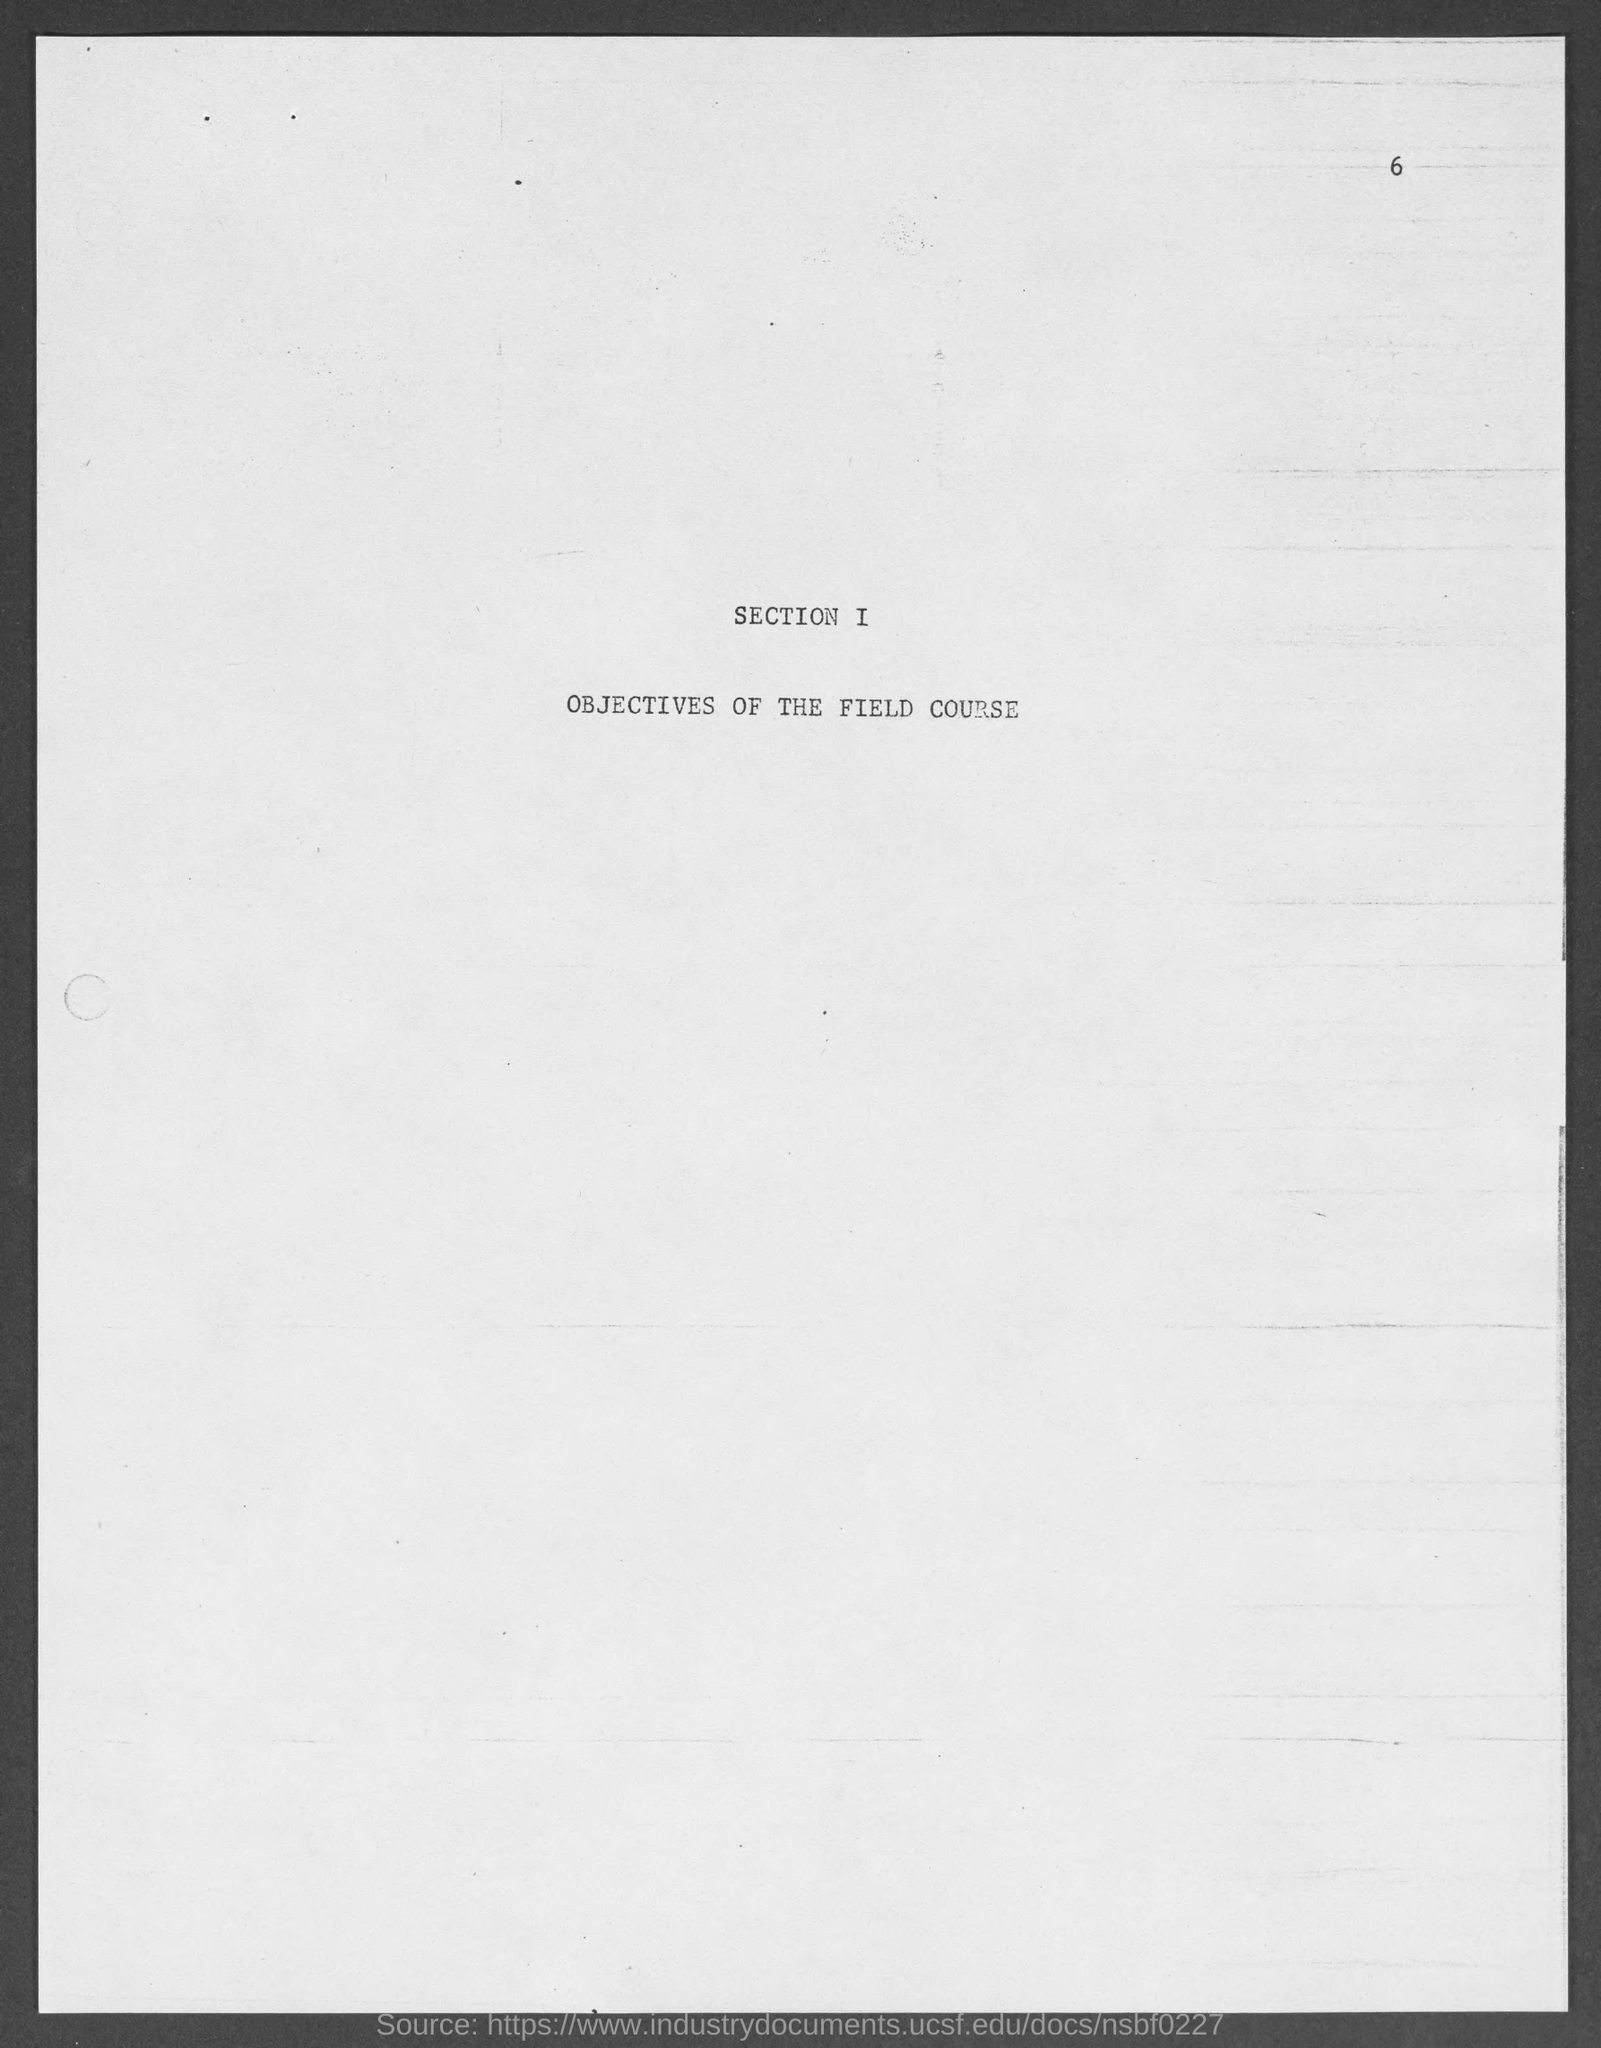What is the page number at top of the page?
Offer a terse response. 6. What does section i belongs to?
Offer a terse response. Objectives of the Field Course. 